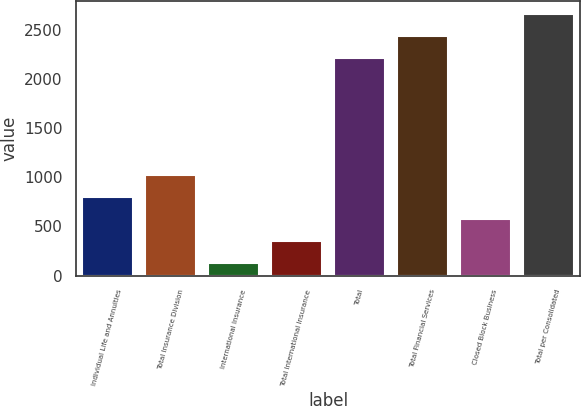<chart> <loc_0><loc_0><loc_500><loc_500><bar_chart><fcel>Individual Life and Annuities<fcel>Total Insurance Division<fcel>International Insurance<fcel>Total International Insurance<fcel>Total<fcel>Total Financial Services<fcel>Closed Block Business<fcel>Total per Consolidated<nl><fcel>798<fcel>1021<fcel>129<fcel>352<fcel>2220<fcel>2443<fcel>575<fcel>2666<nl></chart> 